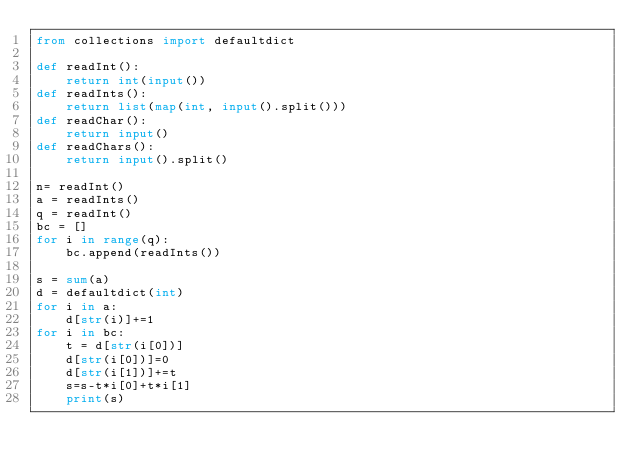Convert code to text. <code><loc_0><loc_0><loc_500><loc_500><_Python_>from collections import defaultdict

def readInt():
	return int(input())
def readInts():
	return list(map(int, input().split()))
def readChar():
	return input()
def readChars():
	return input().split()

n= readInt()
a = readInts()
q = readInt()
bc = []
for i in range(q):
	bc.append(readInts())

s = sum(a)
d = defaultdict(int)
for i in a:
	d[str(i)]+=1
for i in bc:
	t = d[str(i[0])]
	d[str(i[0])]=0
	d[str(i[1])]+=t
	s=s-t*i[0]+t*i[1]
	print(s)</code> 